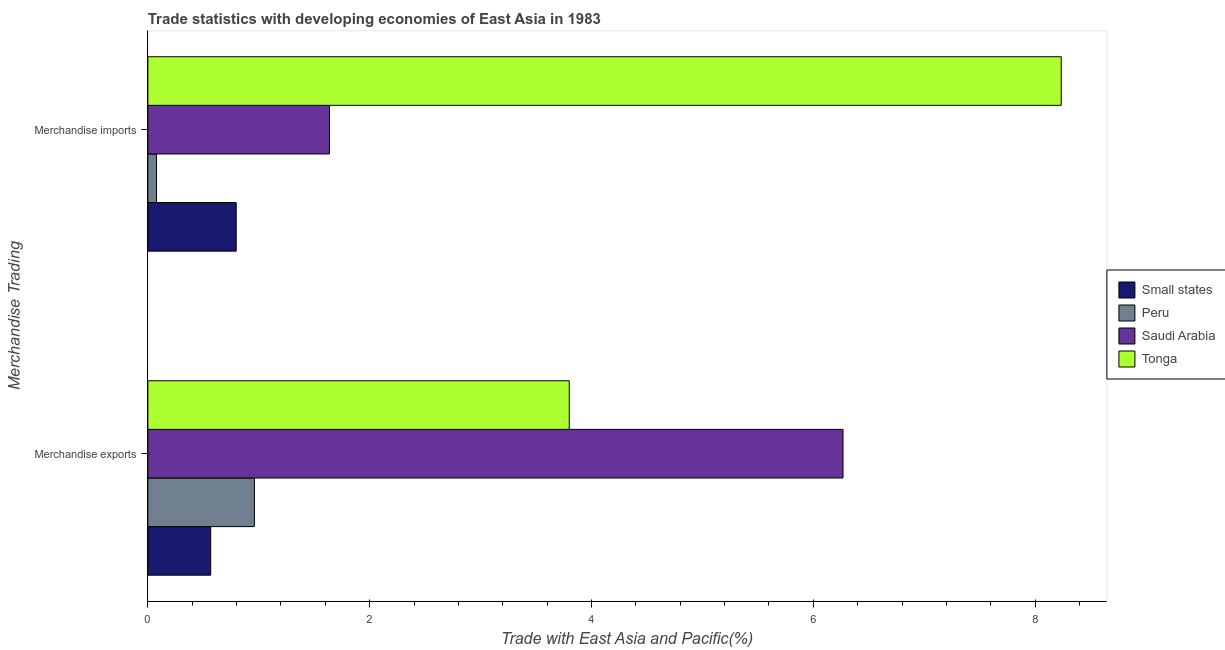What is the label of the 1st group of bars from the top?
Your answer should be very brief. Merchandise imports. What is the merchandise exports in Small states?
Your answer should be very brief. 0.57. Across all countries, what is the maximum merchandise exports?
Your answer should be compact. 6.27. Across all countries, what is the minimum merchandise imports?
Offer a very short reply. 0.08. In which country was the merchandise imports maximum?
Your answer should be compact. Tonga. In which country was the merchandise exports minimum?
Give a very brief answer. Small states. What is the total merchandise exports in the graph?
Your response must be concise. 11.59. What is the difference between the merchandise exports in Tonga and that in Peru?
Give a very brief answer. 2.84. What is the difference between the merchandise imports in Peru and the merchandise exports in Small states?
Keep it short and to the point. -0.49. What is the average merchandise imports per country?
Provide a short and direct response. 2.69. What is the difference between the merchandise exports and merchandise imports in Tonga?
Give a very brief answer. -4.44. What is the ratio of the merchandise exports in Tonga to that in Peru?
Offer a terse response. 3.95. Is the merchandise imports in Small states less than that in Tonga?
Offer a terse response. Yes. What does the 4th bar from the top in Merchandise imports represents?
Offer a very short reply. Small states. What does the 4th bar from the bottom in Merchandise exports represents?
Keep it short and to the point. Tonga. Are all the bars in the graph horizontal?
Your response must be concise. Yes. What is the difference between two consecutive major ticks on the X-axis?
Offer a very short reply. 2. Are the values on the major ticks of X-axis written in scientific E-notation?
Provide a short and direct response. No. Does the graph contain any zero values?
Make the answer very short. No. Where does the legend appear in the graph?
Offer a very short reply. Center right. How many legend labels are there?
Give a very brief answer. 4. What is the title of the graph?
Give a very brief answer. Trade statistics with developing economies of East Asia in 1983. What is the label or title of the X-axis?
Your response must be concise. Trade with East Asia and Pacific(%). What is the label or title of the Y-axis?
Make the answer very short. Merchandise Trading. What is the Trade with East Asia and Pacific(%) in Small states in Merchandise exports?
Make the answer very short. 0.57. What is the Trade with East Asia and Pacific(%) in Peru in Merchandise exports?
Give a very brief answer. 0.96. What is the Trade with East Asia and Pacific(%) in Saudi Arabia in Merchandise exports?
Keep it short and to the point. 6.27. What is the Trade with East Asia and Pacific(%) in Tonga in Merchandise exports?
Offer a terse response. 3.8. What is the Trade with East Asia and Pacific(%) in Small states in Merchandise imports?
Offer a very short reply. 0.8. What is the Trade with East Asia and Pacific(%) of Peru in Merchandise imports?
Offer a very short reply. 0.08. What is the Trade with East Asia and Pacific(%) in Saudi Arabia in Merchandise imports?
Your answer should be very brief. 1.64. What is the Trade with East Asia and Pacific(%) in Tonga in Merchandise imports?
Provide a succinct answer. 8.24. Across all Merchandise Trading, what is the maximum Trade with East Asia and Pacific(%) of Small states?
Make the answer very short. 0.8. Across all Merchandise Trading, what is the maximum Trade with East Asia and Pacific(%) of Peru?
Your answer should be compact. 0.96. Across all Merchandise Trading, what is the maximum Trade with East Asia and Pacific(%) of Saudi Arabia?
Ensure brevity in your answer.  6.27. Across all Merchandise Trading, what is the maximum Trade with East Asia and Pacific(%) in Tonga?
Your response must be concise. 8.24. Across all Merchandise Trading, what is the minimum Trade with East Asia and Pacific(%) in Small states?
Make the answer very short. 0.57. Across all Merchandise Trading, what is the minimum Trade with East Asia and Pacific(%) in Peru?
Your answer should be very brief. 0.08. Across all Merchandise Trading, what is the minimum Trade with East Asia and Pacific(%) in Saudi Arabia?
Provide a short and direct response. 1.64. Across all Merchandise Trading, what is the minimum Trade with East Asia and Pacific(%) of Tonga?
Make the answer very short. 3.8. What is the total Trade with East Asia and Pacific(%) in Small states in the graph?
Keep it short and to the point. 1.36. What is the total Trade with East Asia and Pacific(%) of Peru in the graph?
Your answer should be compact. 1.04. What is the total Trade with East Asia and Pacific(%) of Saudi Arabia in the graph?
Give a very brief answer. 7.91. What is the total Trade with East Asia and Pacific(%) of Tonga in the graph?
Your answer should be very brief. 12.03. What is the difference between the Trade with East Asia and Pacific(%) in Small states in Merchandise exports and that in Merchandise imports?
Your response must be concise. -0.23. What is the difference between the Trade with East Asia and Pacific(%) in Peru in Merchandise exports and that in Merchandise imports?
Offer a terse response. 0.88. What is the difference between the Trade with East Asia and Pacific(%) in Saudi Arabia in Merchandise exports and that in Merchandise imports?
Give a very brief answer. 4.63. What is the difference between the Trade with East Asia and Pacific(%) in Tonga in Merchandise exports and that in Merchandise imports?
Keep it short and to the point. -4.44. What is the difference between the Trade with East Asia and Pacific(%) of Small states in Merchandise exports and the Trade with East Asia and Pacific(%) of Peru in Merchandise imports?
Your answer should be very brief. 0.49. What is the difference between the Trade with East Asia and Pacific(%) in Small states in Merchandise exports and the Trade with East Asia and Pacific(%) in Saudi Arabia in Merchandise imports?
Offer a very short reply. -1.07. What is the difference between the Trade with East Asia and Pacific(%) in Small states in Merchandise exports and the Trade with East Asia and Pacific(%) in Tonga in Merchandise imports?
Offer a terse response. -7.67. What is the difference between the Trade with East Asia and Pacific(%) of Peru in Merchandise exports and the Trade with East Asia and Pacific(%) of Saudi Arabia in Merchandise imports?
Give a very brief answer. -0.68. What is the difference between the Trade with East Asia and Pacific(%) in Peru in Merchandise exports and the Trade with East Asia and Pacific(%) in Tonga in Merchandise imports?
Your answer should be very brief. -7.27. What is the difference between the Trade with East Asia and Pacific(%) in Saudi Arabia in Merchandise exports and the Trade with East Asia and Pacific(%) in Tonga in Merchandise imports?
Keep it short and to the point. -1.97. What is the average Trade with East Asia and Pacific(%) in Small states per Merchandise Trading?
Make the answer very short. 0.68. What is the average Trade with East Asia and Pacific(%) in Peru per Merchandise Trading?
Provide a succinct answer. 0.52. What is the average Trade with East Asia and Pacific(%) in Saudi Arabia per Merchandise Trading?
Keep it short and to the point. 3.95. What is the average Trade with East Asia and Pacific(%) in Tonga per Merchandise Trading?
Your answer should be compact. 6.02. What is the difference between the Trade with East Asia and Pacific(%) in Small states and Trade with East Asia and Pacific(%) in Peru in Merchandise exports?
Provide a succinct answer. -0.39. What is the difference between the Trade with East Asia and Pacific(%) in Small states and Trade with East Asia and Pacific(%) in Saudi Arabia in Merchandise exports?
Keep it short and to the point. -5.7. What is the difference between the Trade with East Asia and Pacific(%) of Small states and Trade with East Asia and Pacific(%) of Tonga in Merchandise exports?
Provide a succinct answer. -3.23. What is the difference between the Trade with East Asia and Pacific(%) of Peru and Trade with East Asia and Pacific(%) of Saudi Arabia in Merchandise exports?
Your response must be concise. -5.31. What is the difference between the Trade with East Asia and Pacific(%) of Peru and Trade with East Asia and Pacific(%) of Tonga in Merchandise exports?
Your answer should be compact. -2.84. What is the difference between the Trade with East Asia and Pacific(%) in Saudi Arabia and Trade with East Asia and Pacific(%) in Tonga in Merchandise exports?
Provide a succinct answer. 2.47. What is the difference between the Trade with East Asia and Pacific(%) in Small states and Trade with East Asia and Pacific(%) in Peru in Merchandise imports?
Keep it short and to the point. 0.72. What is the difference between the Trade with East Asia and Pacific(%) in Small states and Trade with East Asia and Pacific(%) in Saudi Arabia in Merchandise imports?
Keep it short and to the point. -0.84. What is the difference between the Trade with East Asia and Pacific(%) of Small states and Trade with East Asia and Pacific(%) of Tonga in Merchandise imports?
Offer a terse response. -7.44. What is the difference between the Trade with East Asia and Pacific(%) of Peru and Trade with East Asia and Pacific(%) of Saudi Arabia in Merchandise imports?
Offer a terse response. -1.56. What is the difference between the Trade with East Asia and Pacific(%) in Peru and Trade with East Asia and Pacific(%) in Tonga in Merchandise imports?
Provide a succinct answer. -8.16. What is the difference between the Trade with East Asia and Pacific(%) in Saudi Arabia and Trade with East Asia and Pacific(%) in Tonga in Merchandise imports?
Give a very brief answer. -6.6. What is the ratio of the Trade with East Asia and Pacific(%) in Small states in Merchandise exports to that in Merchandise imports?
Your answer should be very brief. 0.71. What is the ratio of the Trade with East Asia and Pacific(%) in Peru in Merchandise exports to that in Merchandise imports?
Ensure brevity in your answer.  12.29. What is the ratio of the Trade with East Asia and Pacific(%) in Saudi Arabia in Merchandise exports to that in Merchandise imports?
Keep it short and to the point. 3.83. What is the ratio of the Trade with East Asia and Pacific(%) of Tonga in Merchandise exports to that in Merchandise imports?
Offer a very short reply. 0.46. What is the difference between the highest and the second highest Trade with East Asia and Pacific(%) of Small states?
Offer a terse response. 0.23. What is the difference between the highest and the second highest Trade with East Asia and Pacific(%) of Peru?
Ensure brevity in your answer.  0.88. What is the difference between the highest and the second highest Trade with East Asia and Pacific(%) in Saudi Arabia?
Your answer should be compact. 4.63. What is the difference between the highest and the second highest Trade with East Asia and Pacific(%) of Tonga?
Give a very brief answer. 4.44. What is the difference between the highest and the lowest Trade with East Asia and Pacific(%) in Small states?
Your answer should be very brief. 0.23. What is the difference between the highest and the lowest Trade with East Asia and Pacific(%) of Peru?
Provide a succinct answer. 0.88. What is the difference between the highest and the lowest Trade with East Asia and Pacific(%) in Saudi Arabia?
Your response must be concise. 4.63. What is the difference between the highest and the lowest Trade with East Asia and Pacific(%) in Tonga?
Offer a terse response. 4.44. 